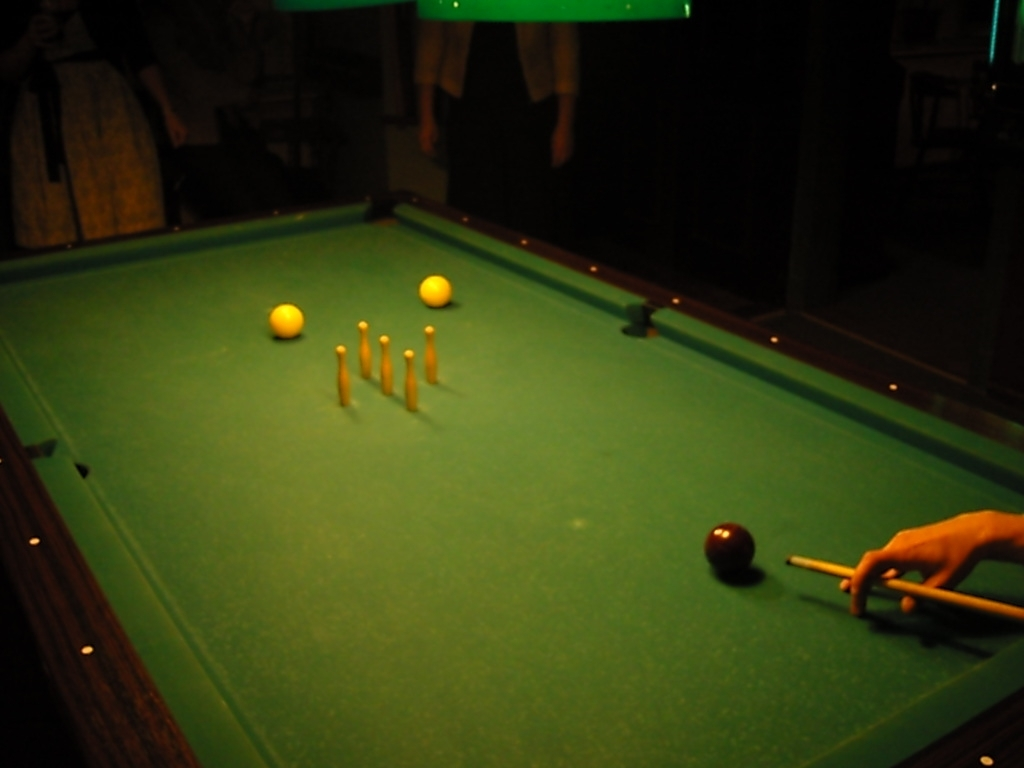What can be inferred about the skill level of the players? Inferring from the arrangement of the balls and the player's stance, it seems the players are quite familiar with the game. The grip on the cue stick and the careful aim for a shot suggest experience and knowledge of game techniques, indicating a moderate to high skill level. 